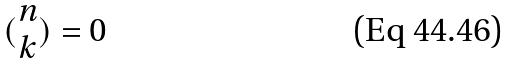<formula> <loc_0><loc_0><loc_500><loc_500>( \begin{matrix} n \\ k \end{matrix} ) = 0</formula> 